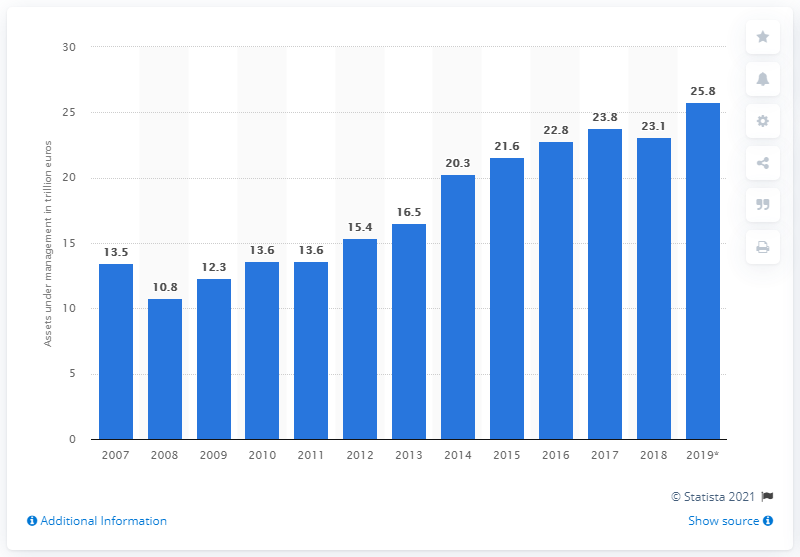Identify some key points in this picture. As of 2019, the estimated value of assets under management in Europe was approximately 25.8 trillion US dollars. 